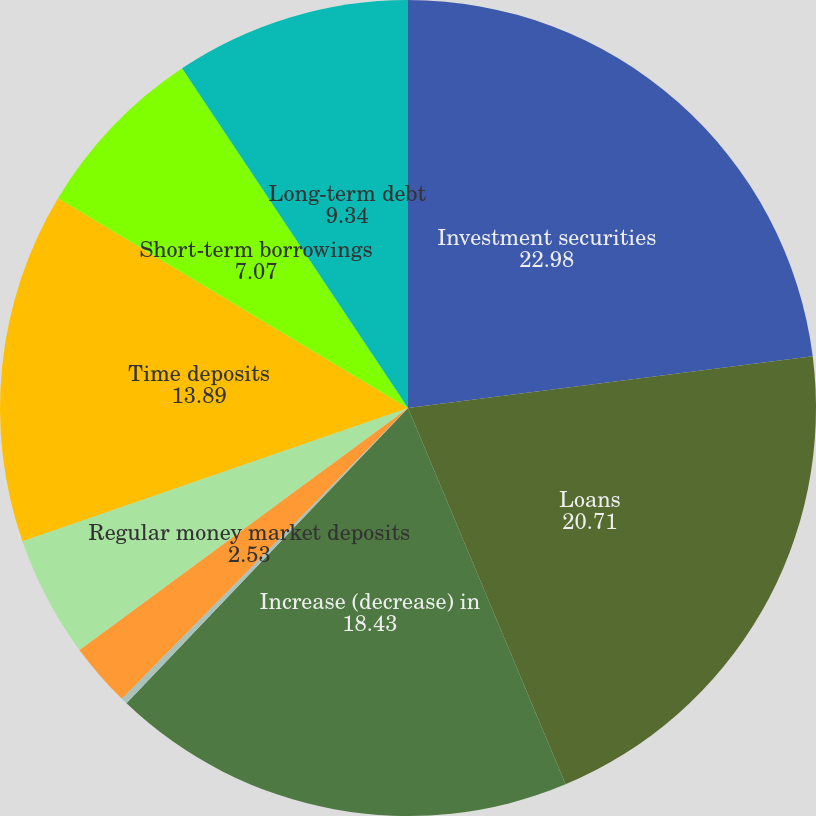Convert chart. <chart><loc_0><loc_0><loc_500><loc_500><pie_chart><fcel>Investment securities<fcel>Loans<fcel>Increase (decrease) in<fcel>NOW deposits<fcel>Regular money market deposits<fcel>Bonus money market deposits<fcel>Time deposits<fcel>Short-term borrowings<fcel>Long-term debt<nl><fcel>22.98%<fcel>20.71%<fcel>18.43%<fcel>0.25%<fcel>2.53%<fcel>4.8%<fcel>13.89%<fcel>7.07%<fcel>9.34%<nl></chart> 